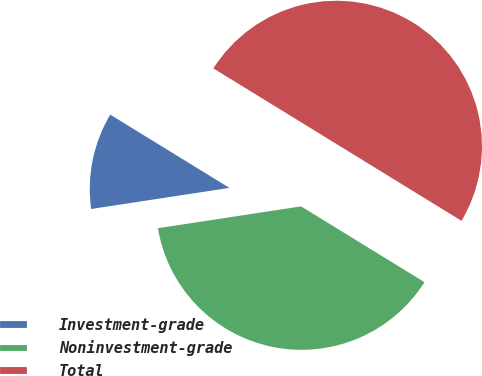Convert chart to OTSL. <chart><loc_0><loc_0><loc_500><loc_500><pie_chart><fcel>Investment-grade<fcel>Noninvestment-grade<fcel>Total<nl><fcel>11.18%<fcel>38.82%<fcel>50.0%<nl></chart> 